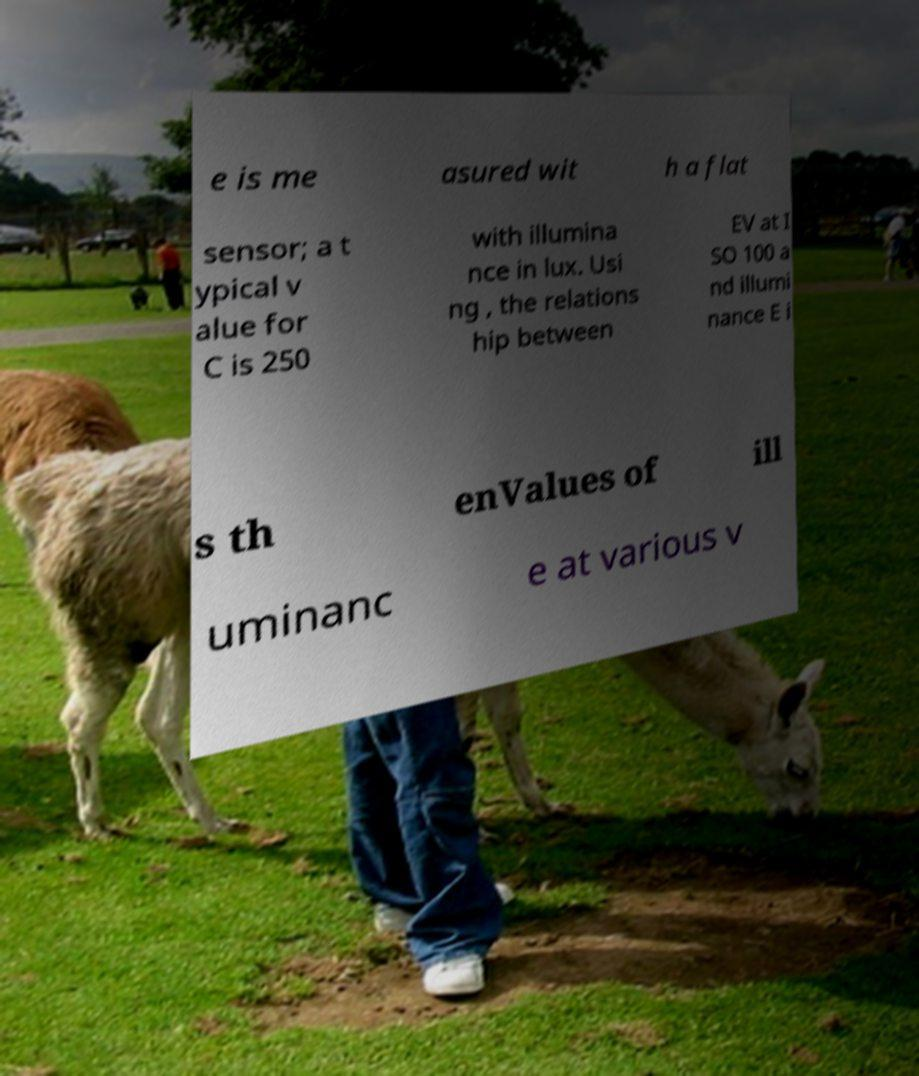I need the written content from this picture converted into text. Can you do that? e is me asured wit h a flat sensor; a t ypical v alue for C is 250 with illumina nce in lux. Usi ng , the relations hip between EV at I SO 100 a nd illumi nance E i s th enValues of ill uminanc e at various v 